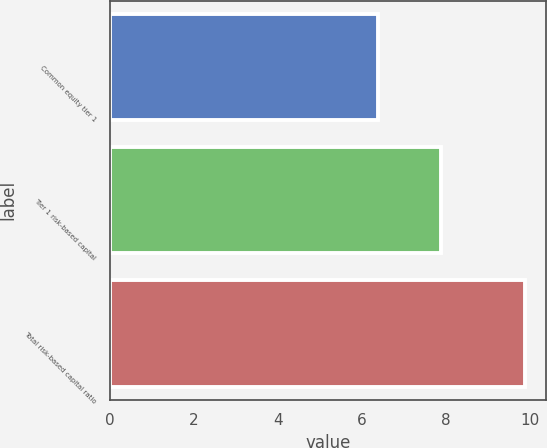Convert chart to OTSL. <chart><loc_0><loc_0><loc_500><loc_500><bar_chart><fcel>Common equity tier 1<fcel>Tier 1 risk-based capital<fcel>Total risk-based capital ratio<nl><fcel>6.38<fcel>7.88<fcel>9.88<nl></chart> 